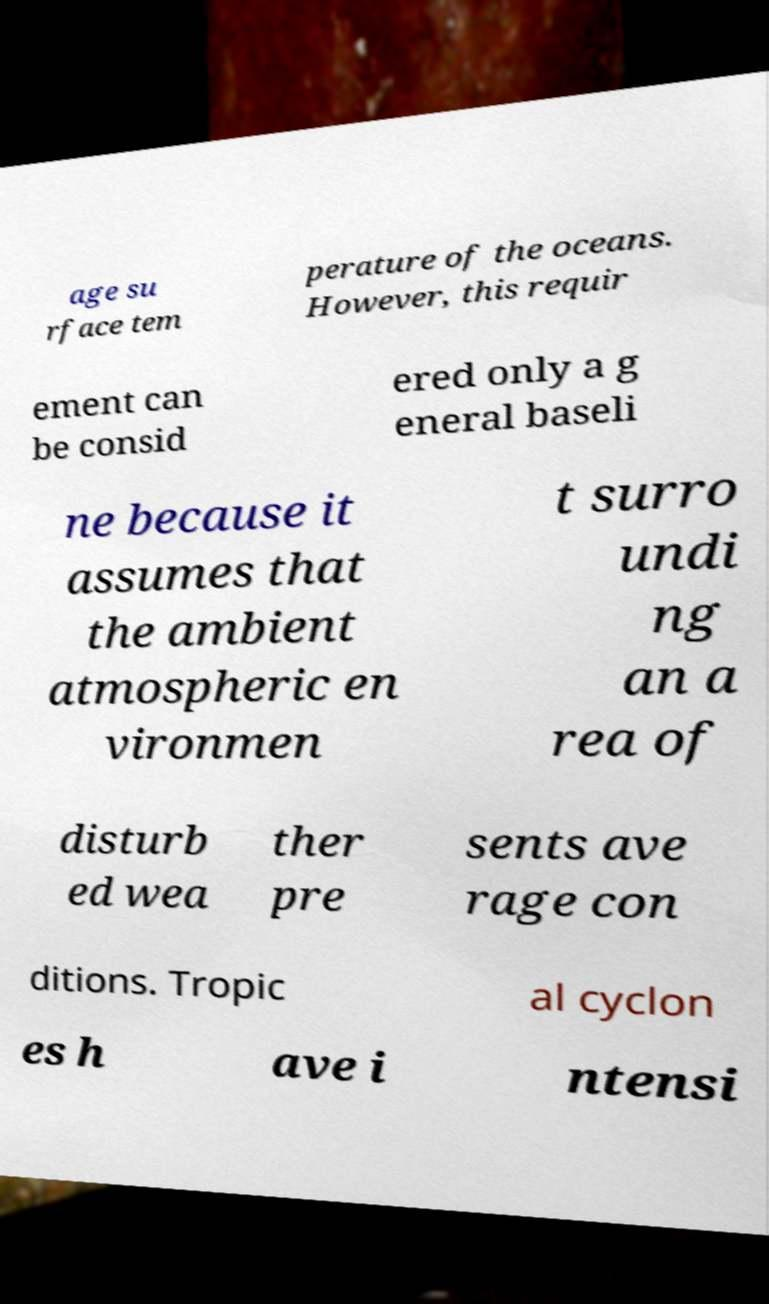Could you extract and type out the text from this image? age su rface tem perature of the oceans. However, this requir ement can be consid ered only a g eneral baseli ne because it assumes that the ambient atmospheric en vironmen t surro undi ng an a rea of disturb ed wea ther pre sents ave rage con ditions. Tropic al cyclon es h ave i ntensi 